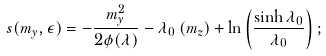<formula> <loc_0><loc_0><loc_500><loc_500>s ( m _ { y } , \epsilon ) = - \frac { m ^ { 2 } _ { y } } { 2 \phi ( \lambda ) } - \lambda _ { 0 } \left ( m _ { z } \right ) + \ln \left ( \frac { \sinh \lambda _ { 0 } } { \lambda _ { 0 } } \right ) ;</formula> 